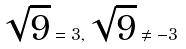<formula> <loc_0><loc_0><loc_500><loc_500>\sqrt { 9 } = 3 , \sqrt { 9 } \ne - 3</formula> 